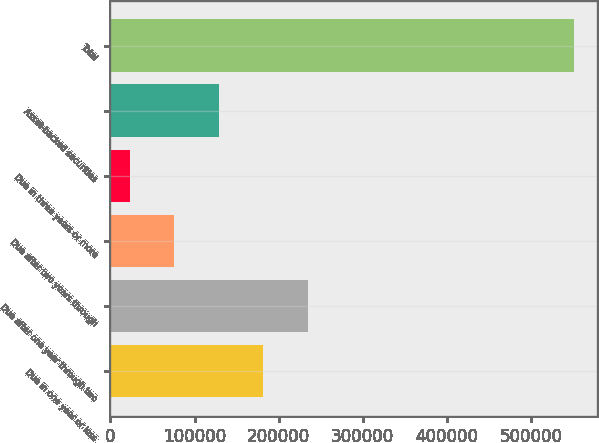Convert chart to OTSL. <chart><loc_0><loc_0><loc_500><loc_500><bar_chart><fcel>Due in one year or less<fcel>Due after one year through two<fcel>Due after two years through<fcel>Due in three years or more<fcel>Asset-backed securities<fcel>Total<nl><fcel>181557<fcel>234394<fcel>75884.4<fcel>23048<fcel>128721<fcel>551412<nl></chart> 